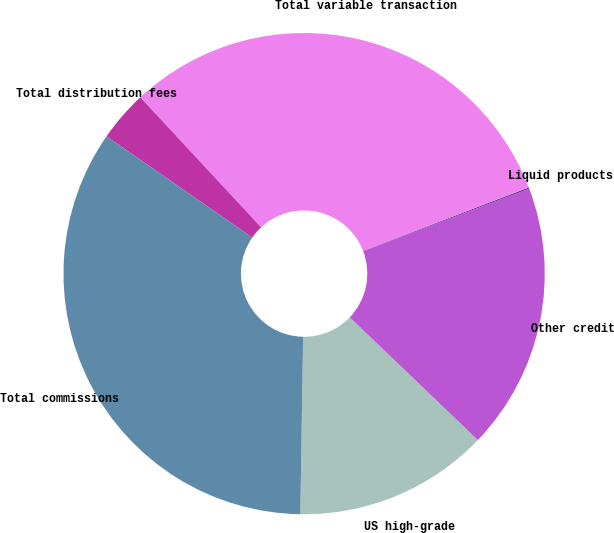<chart> <loc_0><loc_0><loc_500><loc_500><pie_chart><fcel>US high-grade<fcel>Other credit<fcel>Liquid products<fcel>Total variable transaction<fcel>Total distribution fees<fcel>Total commissions<nl><fcel>13.09%<fcel>17.9%<fcel>0.09%<fcel>31.08%<fcel>3.42%<fcel>34.41%<nl></chart> 